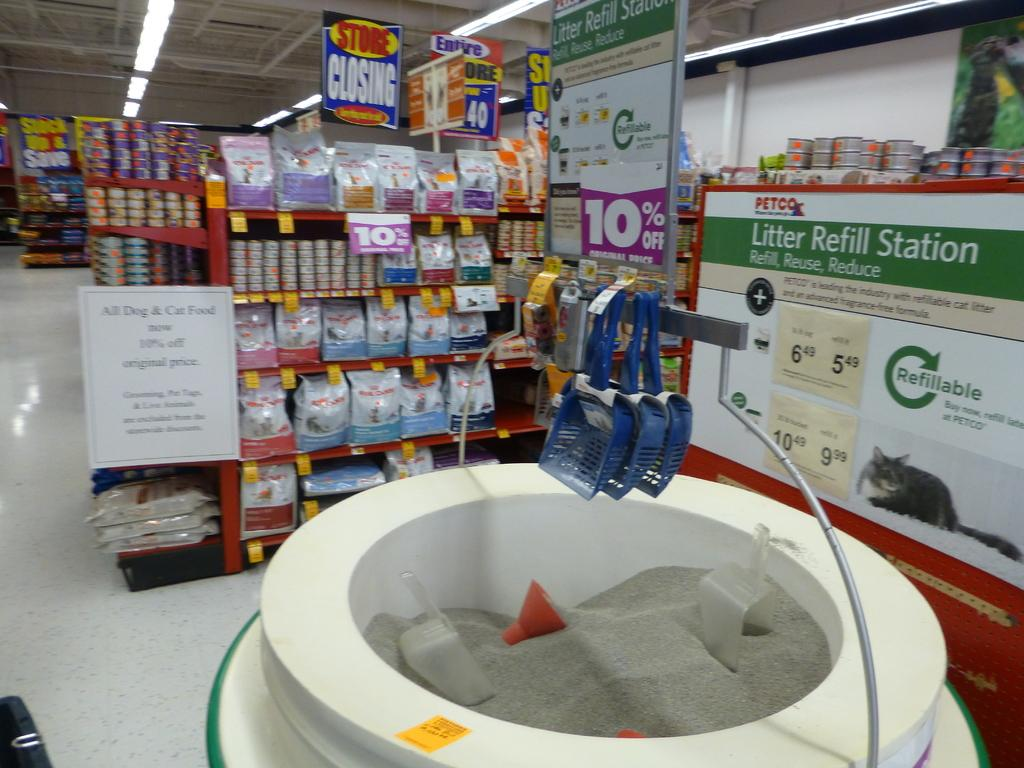Provide a one-sentence caption for the provided image. A litter Refill station located in a PETCO. 